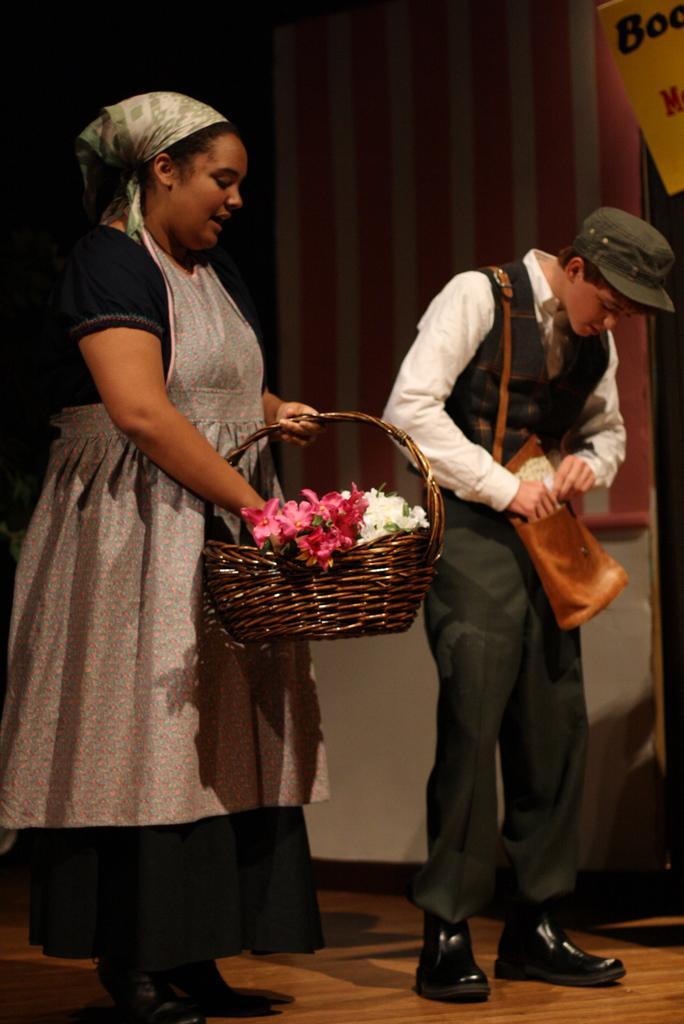Could you give a brief overview of what you see in this image? In the foreground of this picture we can see a woman standing and holding a wooden basket containing flowers. On the right there is a person wearing a cap, sling bag and standing on the floor. In the top right corner we can see the text on the poster. In the background we can see a wall like thing and the some other objects. 